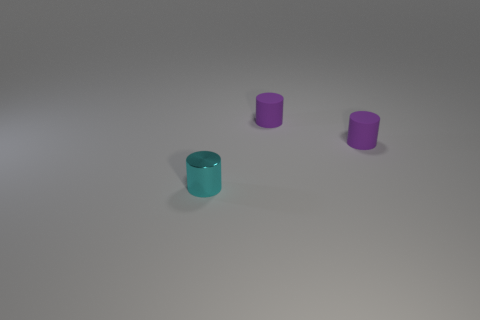Are there more small metal things than objects?
Make the answer very short. No. How many things are rubber cylinders that are on the right side of the small cyan cylinder or small green matte spheres?
Your answer should be very brief. 2. What is the cyan cylinder made of?
Provide a succinct answer. Metal. What number of spheres are either purple matte objects or tiny cyan objects?
Provide a short and direct response. 0. Is there any other thing that has the same material as the cyan cylinder?
Your answer should be compact. No. How many other objects are there of the same color as the metallic cylinder?
Your response must be concise. 0. Is there a metallic cylinder of the same size as the cyan metal object?
Provide a succinct answer. No. Is the number of cyan metal cylinders that are behind the cyan cylinder greater than the number of cyan cylinders?
Make the answer very short. No. Are there any rubber things of the same shape as the cyan shiny object?
Keep it short and to the point. Yes. What is the color of the shiny object?
Offer a very short reply. Cyan. 